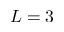<formula> <loc_0><loc_0><loc_500><loc_500>L = 3</formula> 